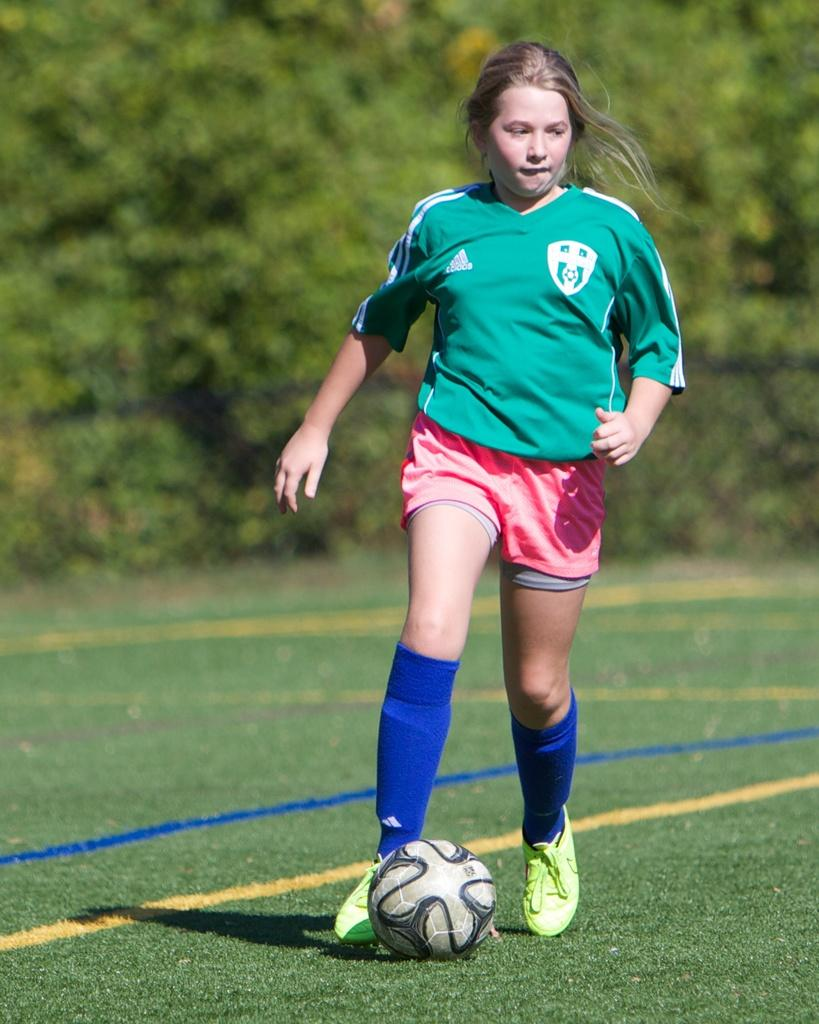Who is the main subject in the image? There is a girl in the image. What is the girl doing in the image? The girl is standing on the ground. What object is in front of the girl? There is a ball in front of the girl. What can be seen in the background of the image? There are trees in the background of the image. What type of coil is wrapped around the trees in the image? There is no coil present in the image; only the girl, the ball, and the trees are visible. 